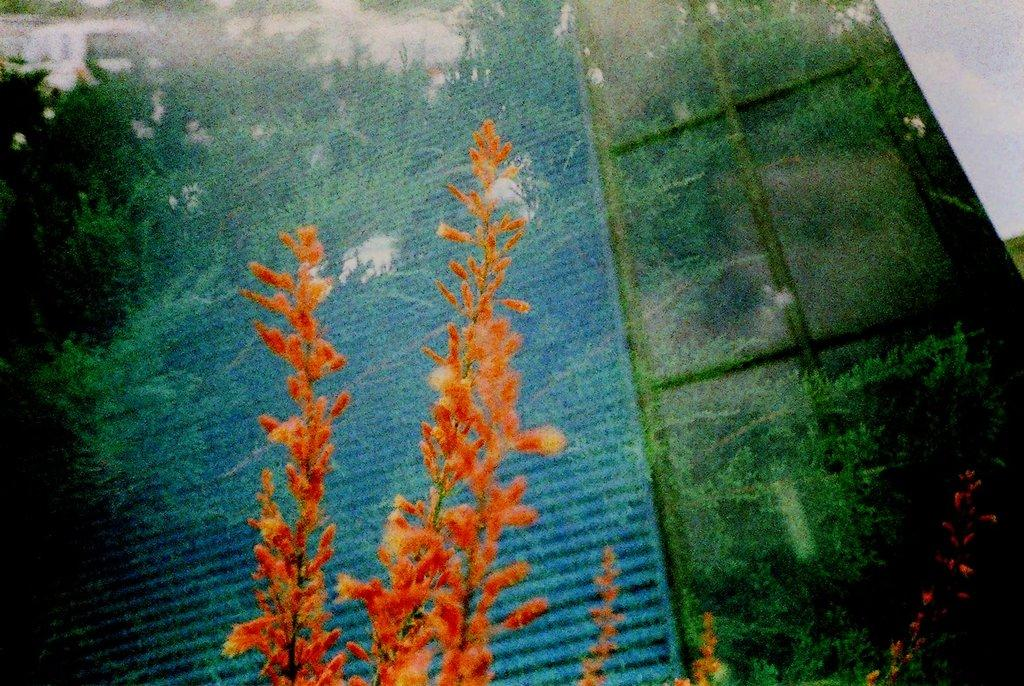What is located in the middle of the image? There are plants in the middle of the image. Can you describe any characteristics of the image? The image appears to be edited. What color are the oranges in the image? There are no oranges present in the image; it features plants in the middle. 